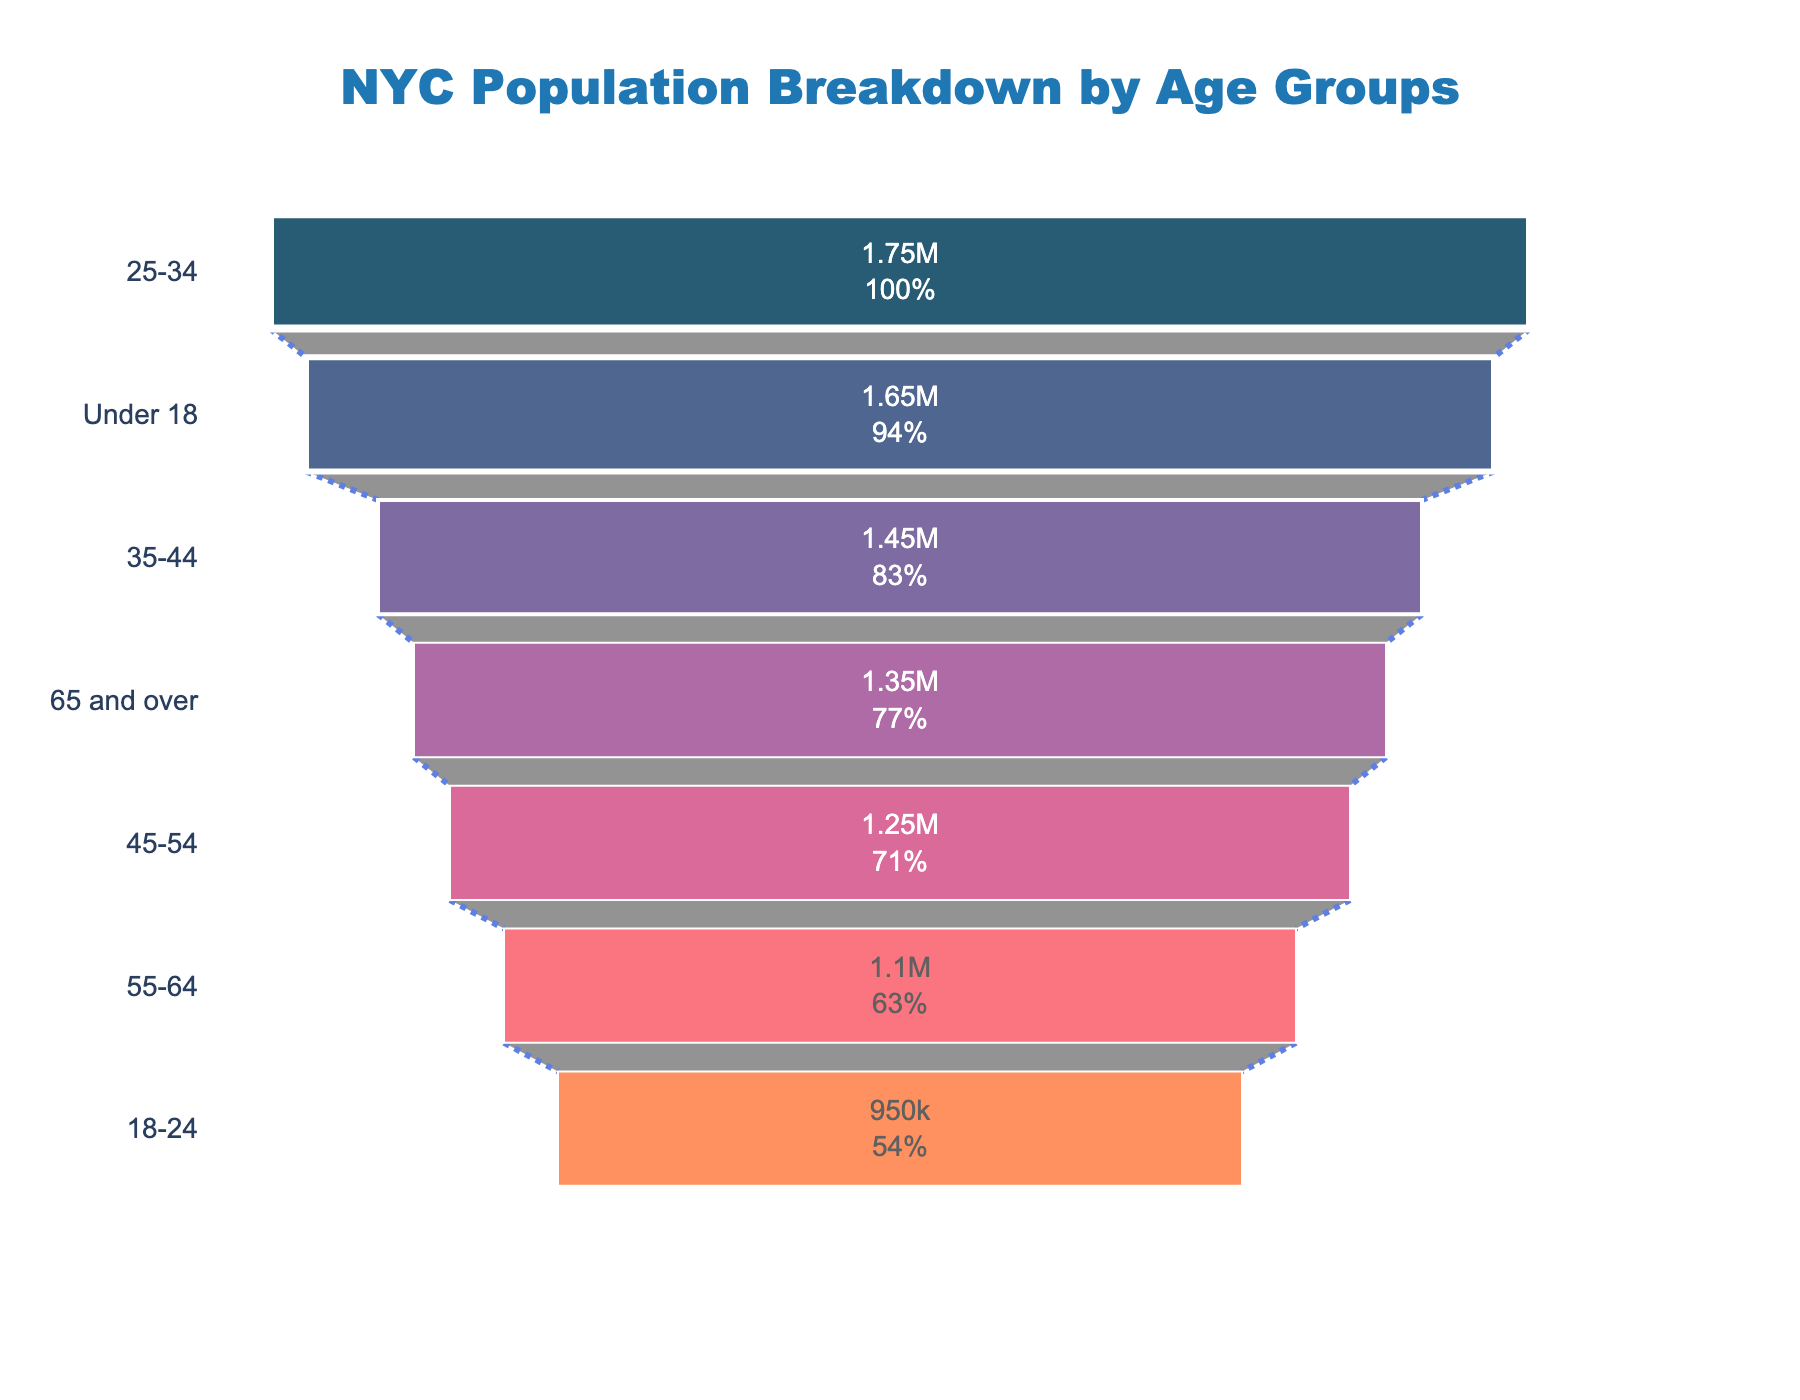What is the title of the figure? The title of the figure is displayed at the top and can be read directly from there.
Answer: NYC Population Breakdown by Age Groups What age group has the smallest population? By visually inspecting the funnel chart, the age group with the smallest section represents the smallest population.
Answer: 18-24 What's the population of the '55-64' age group? The population is displayed inside the funnel section for the '55-64' age group.
Answer: 1,100,000 Compare the population of the age group '35-44' with '45-54'. Which is greater? The funnel for each age group represents its population size. By comparing their sizes, '35-44' is larger.
Answer: 35-44 How many age groups have over 1.5 million people? Count the number of funnel sections that exceed the 1.5 million mark.
Answer: Two age groups What's the combined population of '18-24' and 'Under 18' age groups? Add the populations of '18-24' and 'Under 18' groups: 950,000 + 1,650,000.
Answer: 2,600,000 Which age group makes up the largest percentage of NYC's population? The top section of the funnel chart, which is the widest, represents the largest percentage.
Answer: 25-34 What percentage of NYC's population is aged '65 and over'? The percentage is displayed inside the '65 and over' funnel section.
Answer: Approximately 13% What is the difference in population between the '25-34' and '35-44' age groups? Subtract the population of '35-44' from '25-34': 1,750,000 - 1,450,000.
Answer: 300,000 Which age group is closest to having 1 million people? By comparing the numbers displayed, the closest to 1 million is '55-64' with 1,100,000 people.
Answer: 55-64 